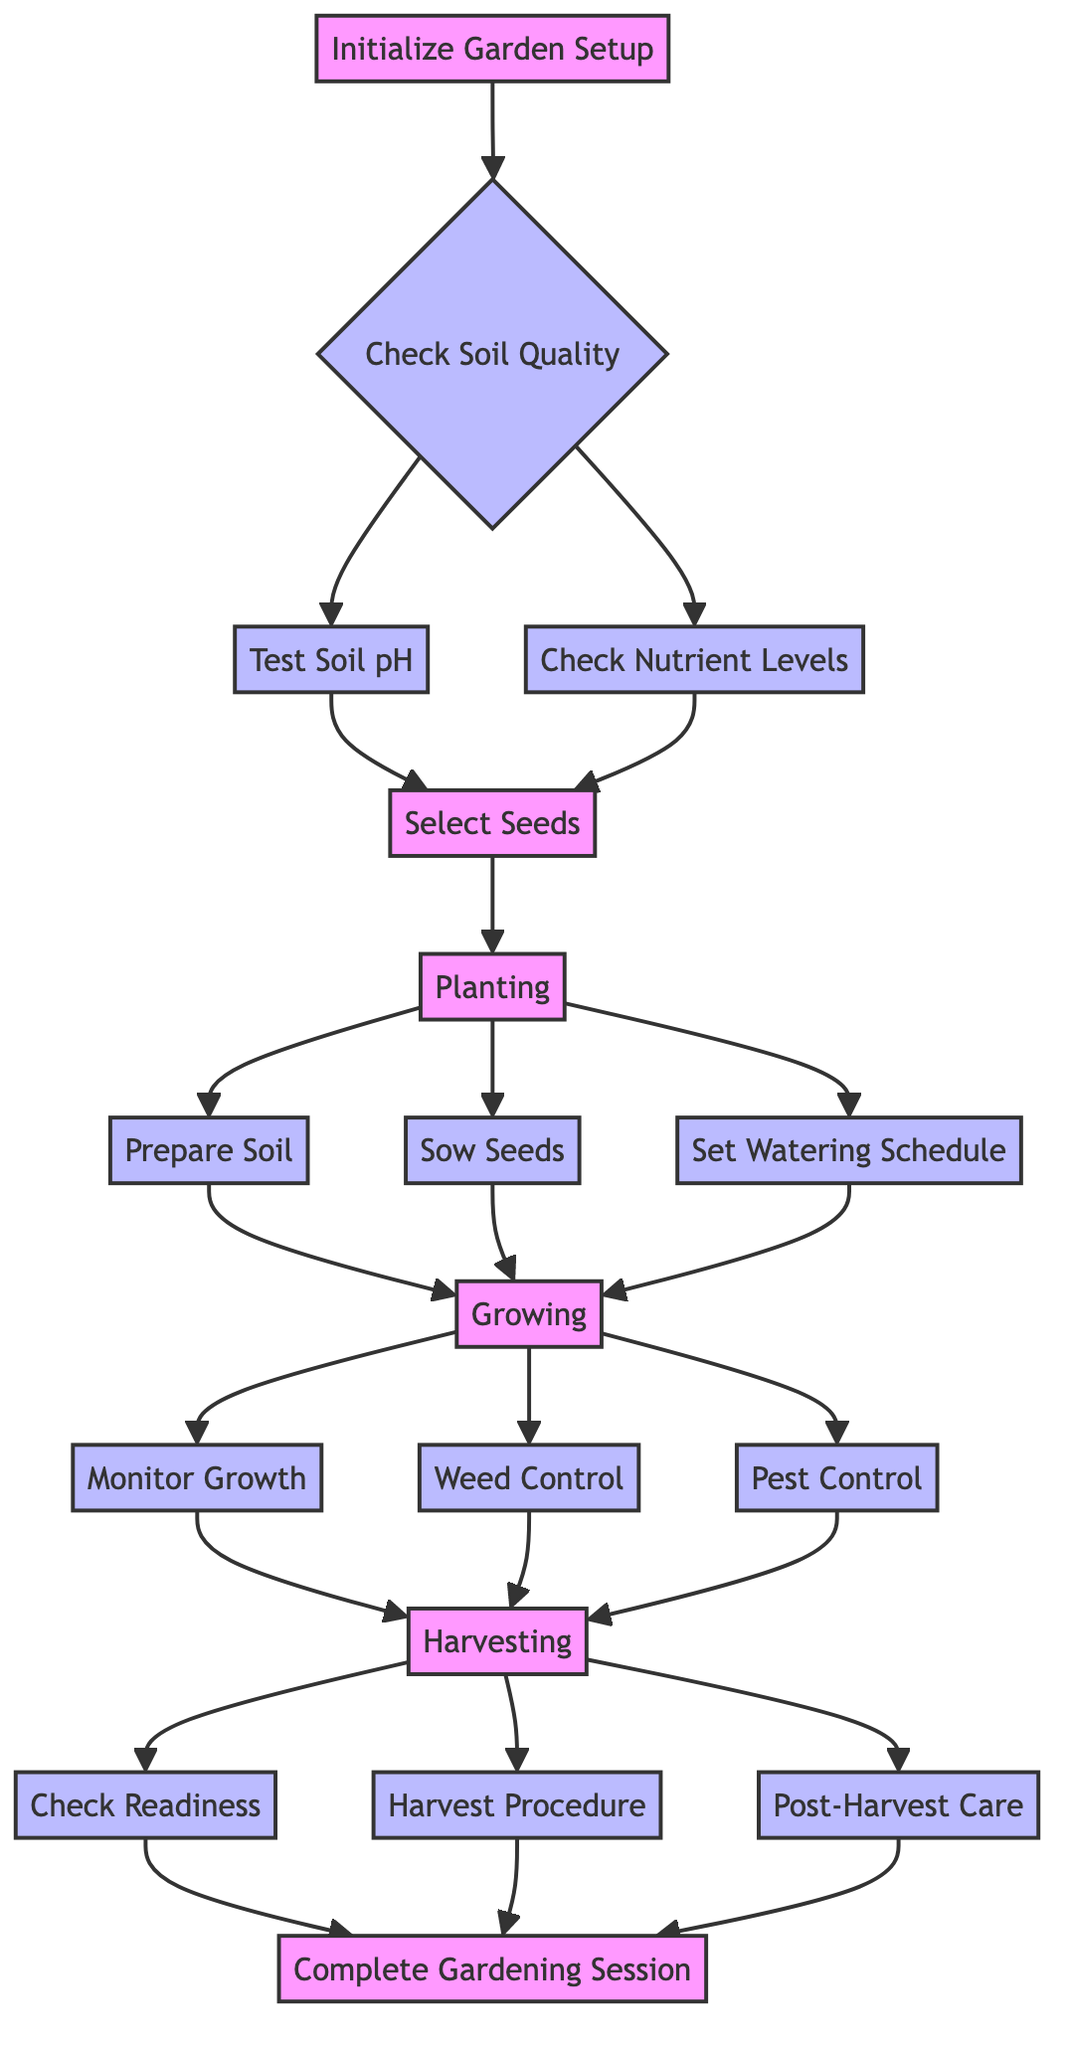What is the first step in the diagram? The first step in the diagram is to "Initialize Garden Setup." This can be identified as the starting node from which all other processes flow.
Answer: Initialize Garden Setup How many nodes are in the growing stage? The growing stage contains three nodes: "Monitor Growth," "Weed Control," and "Pest Control." These nodes represent the different processes involved in the growing phase of the garden.
Answer: 3 What action occurs after "Select Seeds"? After "Select Seeds," the next action is "Planting." This is indicated in the flowchart by the direct connection from "Select Seeds" to "Planting," showing the sequence of tasks.
Answer: Planting Which node directly precedes "Check Readiness"? The node that directly precedes "Check Readiness" is "Growing." This means that you must complete the growing stage before determining the readiness of the vegetables for harvest.
Answer: Growing What is the purpose of "Check Nutrient Levels"? The purpose of "Check Nutrient Levels" is to test the soil for essential nutrients like nitrogen, phosphorus, and potassium (N, P, K) and to add fertilizers if necessary. This ensures the soil has the required nutrients for optimal plant growth.
Answer: Test soil for essential nutrients What are the three actions that occur during the harvesting stage? The three actions that occur during the harvesting stage are "Check Readiness," "Harvest Procedure," and "Post-Harvest Care." Each of these actions is significant for collecting and preserving the vegetables.
Answer: Check Readiness, Harvest Procedure, Post-Harvest Care If "Pest Control" indicates an issue, what is the next step according to the diagram? If "Pest Control" indicates an issue, you would proceed to "Harvesting." However, if no issues are found, the process continues with "Monitor Growth." Both actions are part of the flow from the growing stage to the harvesting stage.
Answer: Harvesting What does the diagram suggest to do if soil pH levels are out of range? If the soil pH levels are out of range (less than 6 or greater than 7.5), the diagram suggests adjusting the soil. This action is necessary to create a suitable growing environment for the plants.
Answer: Adjust soil 